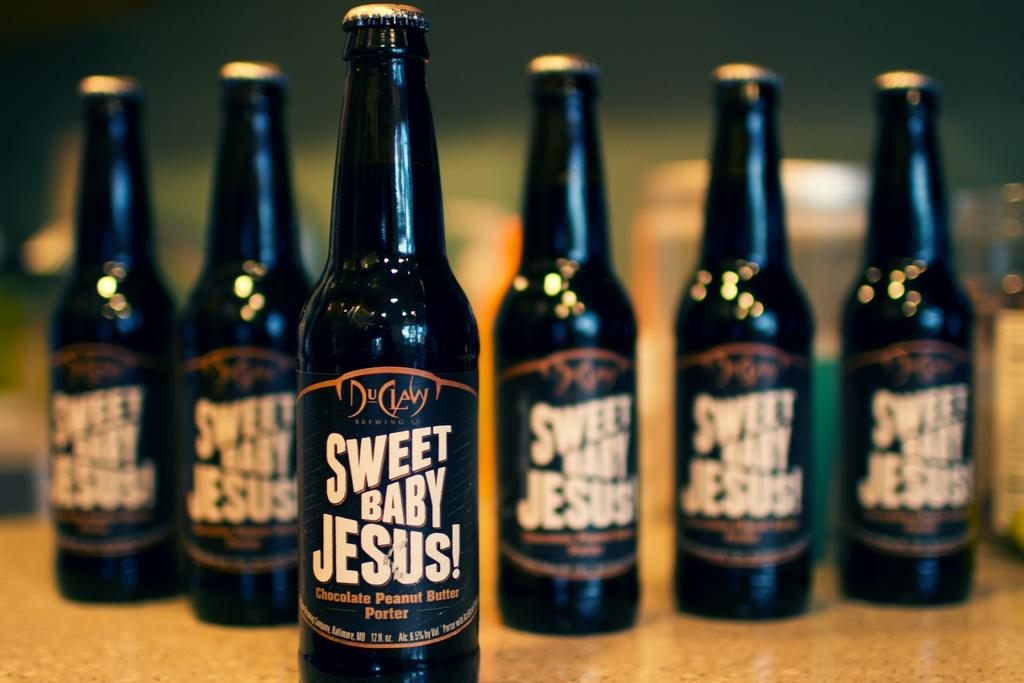<image>
Present a compact description of the photo's key features. Several bottles of Sweet Baby Jesus! chocolate peanut butter porter sit on a table. 